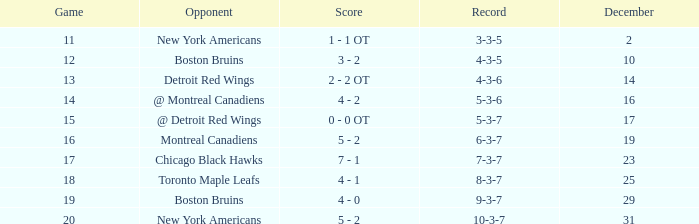Which December has a Record of 4-3-6? 14.0. 